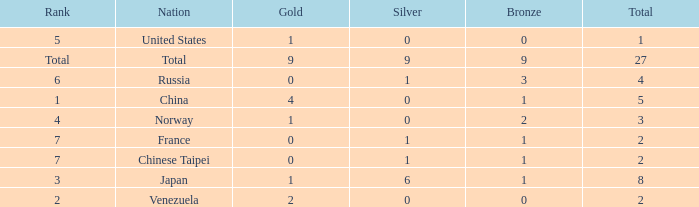What is the total number of Bronze when gold is more than 1 and nation is total? 1.0. 